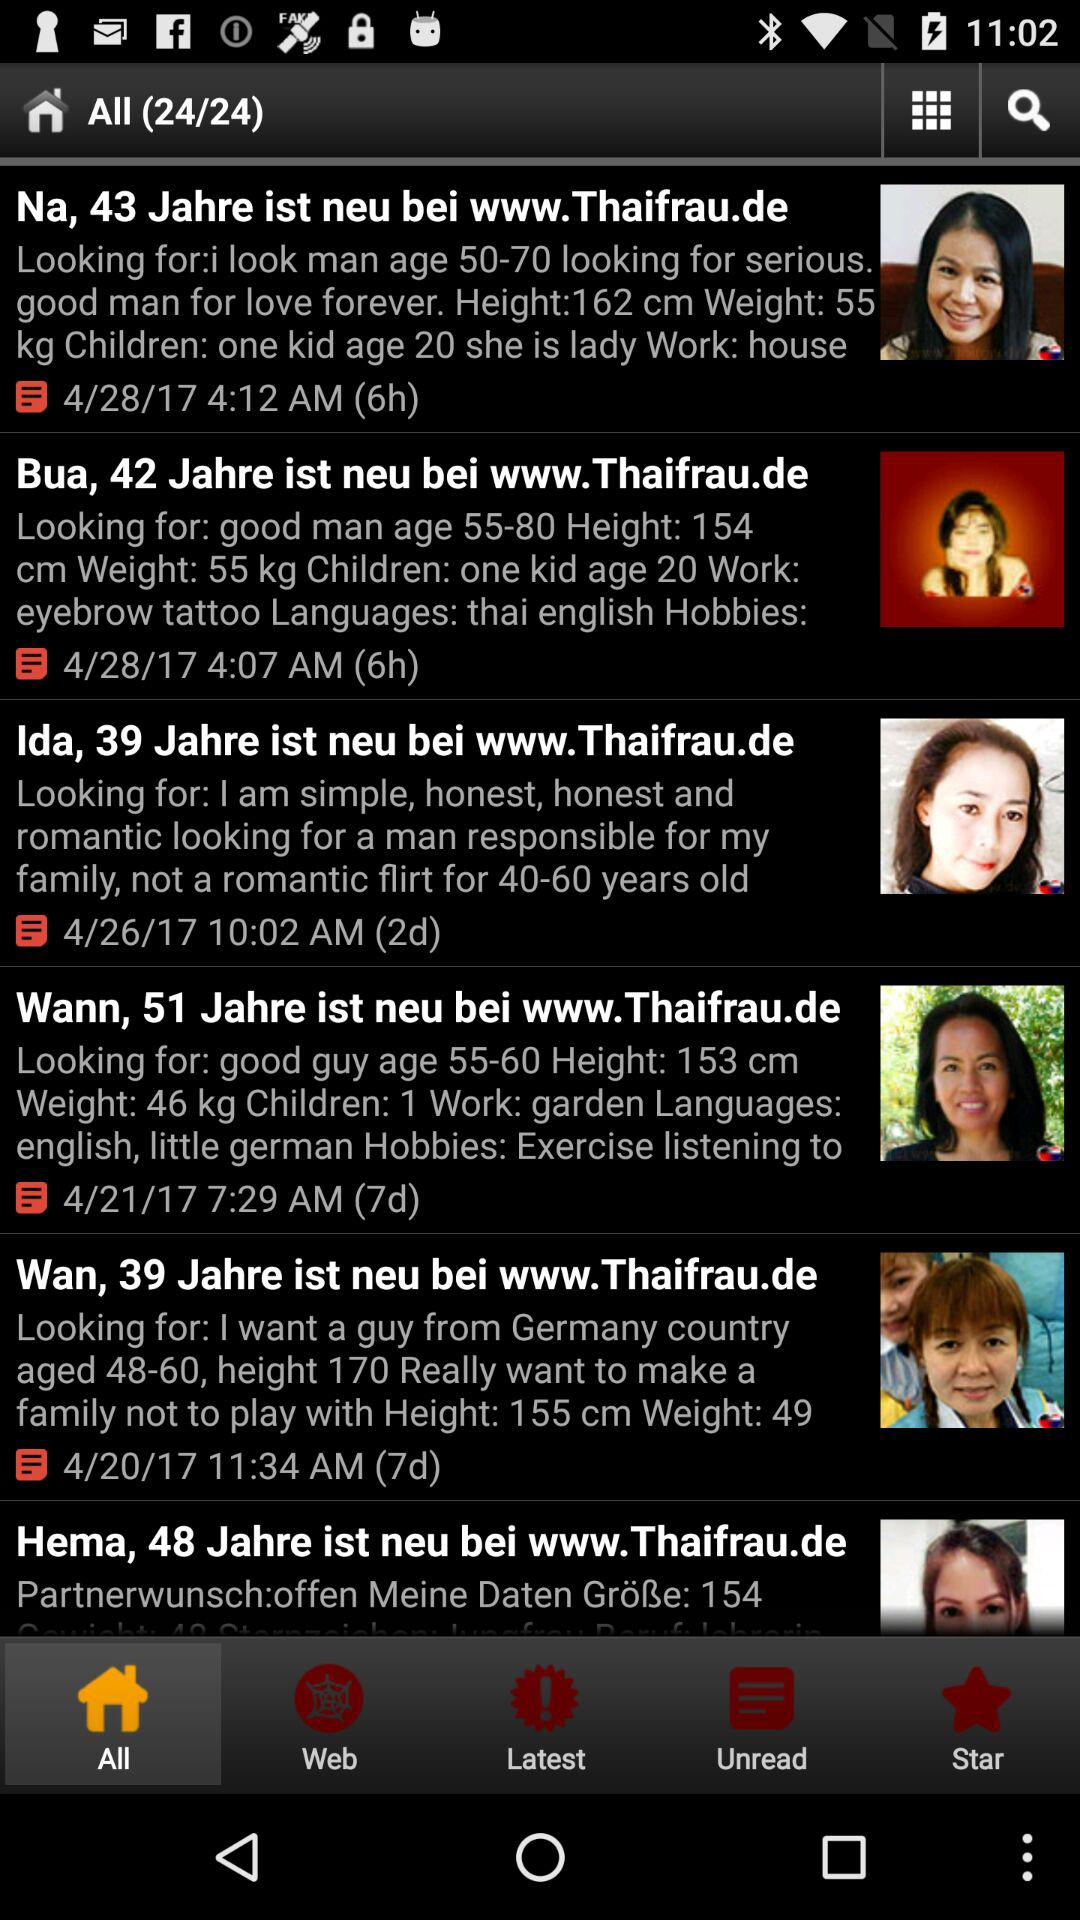How many profile pictures are shown on the screen?
Answer the question using a single word or phrase. 6 